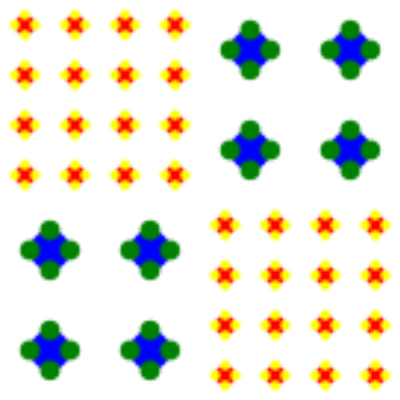In this embroidery design inspired by Ukrainian folklore, how many times is the small floral element repeated compared to the large floral element, and what is the scaling factor between them? To answer this question, we need to analyze the pattern carefully:

1. Identify the floral elements:
   - Small floral element: Red center with four yellow petals
   - Large floral element: Blue center with four green petals

2. Count the repetitions:
   - The design is divided into four quadrants
   - Small floral element appears in two quadrants (top-left and bottom-right)
   - Large floral element appears in two quadrants (top-right and bottom-left)

3. Calculate repetitions within each quadrant:
   - Small floral element: 4 x 4 = 16 repetitions per quadrant
   - Large floral element: 2 x 2 = 4 repetitions per quadrant

4. Total repetitions:
   - Small floral element: 16 x 2 = 32 repetitions
   - Large floral element: 4 x 2 = 8 repetitions

5. Ratio of small to large repetitions:
   $\frac{32}{8} = 4:1$

6. Determine the scaling factor:
   - Small floral element fits in a 50x50 unit square
   - Large floral element fits in a 100x100 unit square
   - Scaling factor: $\frac{100}{50} = 2$

Therefore, the small floral element is repeated 4 times more than the large floral element, and the scaling factor between them is 2.
Answer: 4:1 repetition ratio, 2x scaling factor 